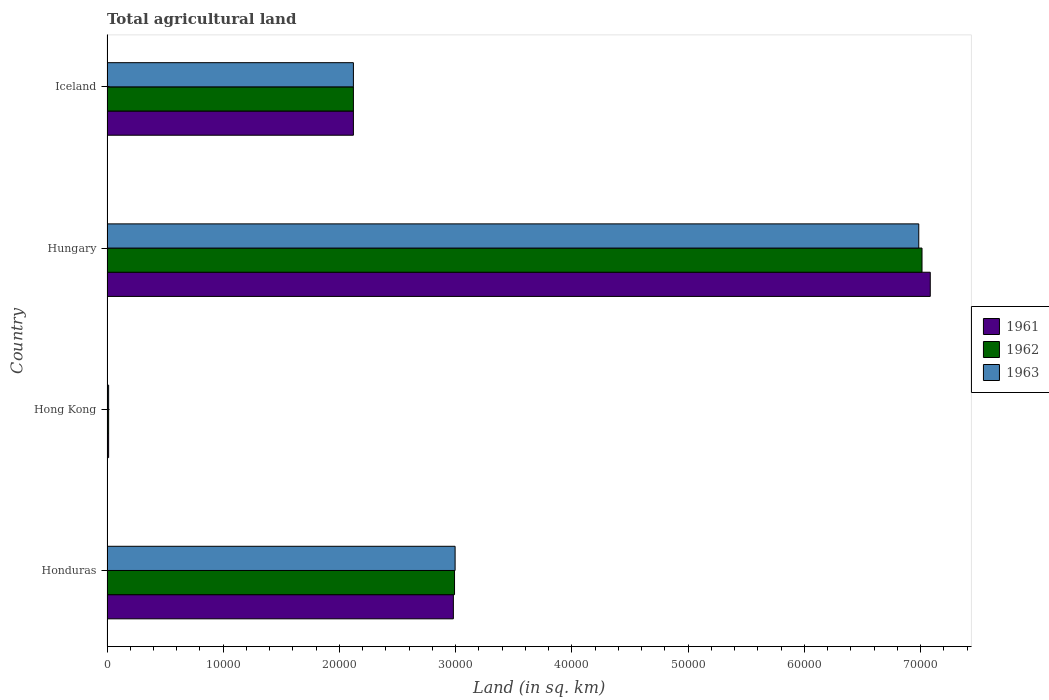How many groups of bars are there?
Keep it short and to the point. 4. Are the number of bars per tick equal to the number of legend labels?
Your answer should be very brief. Yes. How many bars are there on the 3rd tick from the bottom?
Your response must be concise. 3. What is the label of the 2nd group of bars from the top?
Your answer should be very brief. Hungary. In how many cases, is the number of bars for a given country not equal to the number of legend labels?
Give a very brief answer. 0. What is the total agricultural land in 1963 in Hungary?
Ensure brevity in your answer.  6.98e+04. Across all countries, what is the maximum total agricultural land in 1961?
Your answer should be compact. 7.08e+04. Across all countries, what is the minimum total agricultural land in 1962?
Offer a very short reply. 140. In which country was the total agricultural land in 1963 maximum?
Make the answer very short. Hungary. In which country was the total agricultural land in 1962 minimum?
Your answer should be very brief. Hong Kong. What is the total total agricultural land in 1961 in the graph?
Give a very brief answer. 1.22e+05. What is the difference between the total agricultural land in 1961 in Honduras and that in Iceland?
Provide a short and direct response. 8600. What is the difference between the total agricultural land in 1962 in Iceland and the total agricultural land in 1961 in Hungary?
Provide a succinct answer. -4.96e+04. What is the average total agricultural land in 1962 per country?
Give a very brief answer. 3.03e+04. What is the difference between the total agricultural land in 1961 and total agricultural land in 1963 in Honduras?
Offer a very short reply. -150. In how many countries, is the total agricultural land in 1963 greater than 72000 sq.km?
Ensure brevity in your answer.  0. What is the ratio of the total agricultural land in 1961 in Honduras to that in Hong Kong?
Make the answer very short. 212.86. Is the total agricultural land in 1963 in Hong Kong less than that in Iceland?
Offer a very short reply. Yes. What is the difference between the highest and the second highest total agricultural land in 1962?
Ensure brevity in your answer.  4.02e+04. What is the difference between the highest and the lowest total agricultural land in 1961?
Your answer should be compact. 7.07e+04. Is the sum of the total agricultural land in 1961 in Honduras and Hungary greater than the maximum total agricultural land in 1962 across all countries?
Make the answer very short. Yes. What does the 2nd bar from the bottom in Honduras represents?
Give a very brief answer. 1962. Is it the case that in every country, the sum of the total agricultural land in 1961 and total agricultural land in 1962 is greater than the total agricultural land in 1963?
Provide a succinct answer. Yes. Are all the bars in the graph horizontal?
Make the answer very short. Yes. What is the difference between two consecutive major ticks on the X-axis?
Your response must be concise. 10000. Are the values on the major ticks of X-axis written in scientific E-notation?
Ensure brevity in your answer.  No. Does the graph contain any zero values?
Provide a succinct answer. No. Where does the legend appear in the graph?
Give a very brief answer. Center right. What is the title of the graph?
Offer a very short reply. Total agricultural land. What is the label or title of the X-axis?
Provide a succinct answer. Land (in sq. km). What is the Land (in sq. km) in 1961 in Honduras?
Your response must be concise. 2.98e+04. What is the Land (in sq. km) of 1962 in Honduras?
Provide a succinct answer. 2.99e+04. What is the Land (in sq. km) of 1963 in Honduras?
Keep it short and to the point. 3.00e+04. What is the Land (in sq. km) in 1961 in Hong Kong?
Offer a terse response. 140. What is the Land (in sq. km) in 1962 in Hong Kong?
Your answer should be compact. 140. What is the Land (in sq. km) in 1963 in Hong Kong?
Provide a succinct answer. 140. What is the Land (in sq. km) in 1961 in Hungary?
Your answer should be very brief. 7.08e+04. What is the Land (in sq. km) of 1962 in Hungary?
Give a very brief answer. 7.01e+04. What is the Land (in sq. km) of 1963 in Hungary?
Offer a terse response. 6.98e+04. What is the Land (in sq. km) in 1961 in Iceland?
Your response must be concise. 2.12e+04. What is the Land (in sq. km) of 1962 in Iceland?
Your answer should be compact. 2.12e+04. What is the Land (in sq. km) of 1963 in Iceland?
Make the answer very short. 2.12e+04. Across all countries, what is the maximum Land (in sq. km) of 1961?
Your answer should be very brief. 7.08e+04. Across all countries, what is the maximum Land (in sq. km) in 1962?
Provide a short and direct response. 7.01e+04. Across all countries, what is the maximum Land (in sq. km) of 1963?
Make the answer very short. 6.98e+04. Across all countries, what is the minimum Land (in sq. km) of 1961?
Your answer should be very brief. 140. Across all countries, what is the minimum Land (in sq. km) of 1962?
Offer a very short reply. 140. Across all countries, what is the minimum Land (in sq. km) in 1963?
Offer a terse response. 140. What is the total Land (in sq. km) in 1961 in the graph?
Offer a very short reply. 1.22e+05. What is the total Land (in sq. km) of 1962 in the graph?
Your answer should be compact. 1.21e+05. What is the total Land (in sq. km) in 1963 in the graph?
Ensure brevity in your answer.  1.21e+05. What is the difference between the Land (in sq. km) in 1961 in Honduras and that in Hong Kong?
Make the answer very short. 2.97e+04. What is the difference between the Land (in sq. km) in 1962 in Honduras and that in Hong Kong?
Your response must be concise. 2.98e+04. What is the difference between the Land (in sq. km) in 1963 in Honduras and that in Hong Kong?
Provide a succinct answer. 2.98e+04. What is the difference between the Land (in sq. km) of 1961 in Honduras and that in Hungary?
Provide a succinct answer. -4.10e+04. What is the difference between the Land (in sq. km) in 1962 in Honduras and that in Hungary?
Keep it short and to the point. -4.02e+04. What is the difference between the Land (in sq. km) of 1963 in Honduras and that in Hungary?
Keep it short and to the point. -3.99e+04. What is the difference between the Land (in sq. km) in 1961 in Honduras and that in Iceland?
Your answer should be compact. 8600. What is the difference between the Land (in sq. km) of 1962 in Honduras and that in Iceland?
Your answer should be compact. 8700. What is the difference between the Land (in sq. km) of 1963 in Honduras and that in Iceland?
Provide a short and direct response. 8750. What is the difference between the Land (in sq. km) in 1961 in Hong Kong and that in Hungary?
Your answer should be compact. -7.07e+04. What is the difference between the Land (in sq. km) of 1962 in Hong Kong and that in Hungary?
Provide a short and direct response. -7.00e+04. What is the difference between the Land (in sq. km) of 1963 in Hong Kong and that in Hungary?
Provide a succinct answer. -6.97e+04. What is the difference between the Land (in sq. km) of 1961 in Hong Kong and that in Iceland?
Offer a terse response. -2.11e+04. What is the difference between the Land (in sq. km) of 1962 in Hong Kong and that in Iceland?
Make the answer very short. -2.11e+04. What is the difference between the Land (in sq. km) in 1963 in Hong Kong and that in Iceland?
Ensure brevity in your answer.  -2.11e+04. What is the difference between the Land (in sq. km) of 1961 in Hungary and that in Iceland?
Provide a short and direct response. 4.96e+04. What is the difference between the Land (in sq. km) of 1962 in Hungary and that in Iceland?
Keep it short and to the point. 4.89e+04. What is the difference between the Land (in sq. km) in 1963 in Hungary and that in Iceland?
Make the answer very short. 4.86e+04. What is the difference between the Land (in sq. km) of 1961 in Honduras and the Land (in sq. km) of 1962 in Hong Kong?
Give a very brief answer. 2.97e+04. What is the difference between the Land (in sq. km) in 1961 in Honduras and the Land (in sq. km) in 1963 in Hong Kong?
Your answer should be compact. 2.97e+04. What is the difference between the Land (in sq. km) in 1962 in Honduras and the Land (in sq. km) in 1963 in Hong Kong?
Keep it short and to the point. 2.98e+04. What is the difference between the Land (in sq. km) in 1961 in Honduras and the Land (in sq. km) in 1962 in Hungary?
Ensure brevity in your answer.  -4.03e+04. What is the difference between the Land (in sq. km) of 1961 in Honduras and the Land (in sq. km) of 1963 in Hungary?
Your response must be concise. -4.00e+04. What is the difference between the Land (in sq. km) in 1962 in Honduras and the Land (in sq. km) in 1963 in Hungary?
Make the answer very short. -3.99e+04. What is the difference between the Land (in sq. km) of 1961 in Honduras and the Land (in sq. km) of 1962 in Iceland?
Offer a terse response. 8600. What is the difference between the Land (in sq. km) in 1961 in Honduras and the Land (in sq. km) in 1963 in Iceland?
Your response must be concise. 8600. What is the difference between the Land (in sq. km) of 1962 in Honduras and the Land (in sq. km) of 1963 in Iceland?
Ensure brevity in your answer.  8700. What is the difference between the Land (in sq. km) in 1961 in Hong Kong and the Land (in sq. km) in 1962 in Hungary?
Your answer should be compact. -7.00e+04. What is the difference between the Land (in sq. km) of 1961 in Hong Kong and the Land (in sq. km) of 1963 in Hungary?
Your answer should be very brief. -6.97e+04. What is the difference between the Land (in sq. km) of 1962 in Hong Kong and the Land (in sq. km) of 1963 in Hungary?
Provide a short and direct response. -6.97e+04. What is the difference between the Land (in sq. km) in 1961 in Hong Kong and the Land (in sq. km) in 1962 in Iceland?
Ensure brevity in your answer.  -2.11e+04. What is the difference between the Land (in sq. km) in 1961 in Hong Kong and the Land (in sq. km) in 1963 in Iceland?
Your answer should be compact. -2.11e+04. What is the difference between the Land (in sq. km) in 1962 in Hong Kong and the Land (in sq. km) in 1963 in Iceland?
Offer a very short reply. -2.11e+04. What is the difference between the Land (in sq. km) in 1961 in Hungary and the Land (in sq. km) in 1962 in Iceland?
Make the answer very short. 4.96e+04. What is the difference between the Land (in sq. km) in 1961 in Hungary and the Land (in sq. km) in 1963 in Iceland?
Keep it short and to the point. 4.96e+04. What is the difference between the Land (in sq. km) of 1962 in Hungary and the Land (in sq. km) of 1963 in Iceland?
Your answer should be compact. 4.89e+04. What is the average Land (in sq. km) in 1961 per country?
Your response must be concise. 3.05e+04. What is the average Land (in sq. km) of 1962 per country?
Keep it short and to the point. 3.03e+04. What is the average Land (in sq. km) of 1963 per country?
Your answer should be very brief. 3.03e+04. What is the difference between the Land (in sq. km) in 1961 and Land (in sq. km) in 1962 in Honduras?
Offer a very short reply. -100. What is the difference between the Land (in sq. km) of 1961 and Land (in sq. km) of 1963 in Honduras?
Your answer should be very brief. -150. What is the difference between the Land (in sq. km) of 1962 and Land (in sq. km) of 1963 in Honduras?
Your answer should be compact. -50. What is the difference between the Land (in sq. km) of 1961 and Land (in sq. km) of 1962 in Hong Kong?
Provide a short and direct response. 0. What is the difference between the Land (in sq. km) in 1961 and Land (in sq. km) in 1963 in Hong Kong?
Provide a short and direct response. 0. What is the difference between the Land (in sq. km) in 1962 and Land (in sq. km) in 1963 in Hong Kong?
Give a very brief answer. 0. What is the difference between the Land (in sq. km) of 1961 and Land (in sq. km) of 1962 in Hungary?
Provide a succinct answer. 710. What is the difference between the Land (in sq. km) in 1961 and Land (in sq. km) in 1963 in Hungary?
Ensure brevity in your answer.  990. What is the difference between the Land (in sq. km) in 1962 and Land (in sq. km) in 1963 in Hungary?
Make the answer very short. 280. What is the difference between the Land (in sq. km) in 1961 and Land (in sq. km) in 1963 in Iceland?
Your answer should be compact. 0. What is the difference between the Land (in sq. km) in 1962 and Land (in sq. km) in 1963 in Iceland?
Provide a succinct answer. 0. What is the ratio of the Land (in sq. km) in 1961 in Honduras to that in Hong Kong?
Your answer should be very brief. 212.86. What is the ratio of the Land (in sq. km) in 1962 in Honduras to that in Hong Kong?
Offer a very short reply. 213.57. What is the ratio of the Land (in sq. km) of 1963 in Honduras to that in Hong Kong?
Offer a terse response. 213.93. What is the ratio of the Land (in sq. km) in 1961 in Honduras to that in Hungary?
Your answer should be compact. 0.42. What is the ratio of the Land (in sq. km) of 1962 in Honduras to that in Hungary?
Provide a succinct answer. 0.43. What is the ratio of the Land (in sq. km) of 1963 in Honduras to that in Hungary?
Your answer should be compact. 0.43. What is the ratio of the Land (in sq. km) of 1961 in Honduras to that in Iceland?
Your answer should be compact. 1.41. What is the ratio of the Land (in sq. km) of 1962 in Honduras to that in Iceland?
Keep it short and to the point. 1.41. What is the ratio of the Land (in sq. km) in 1963 in Honduras to that in Iceland?
Give a very brief answer. 1.41. What is the ratio of the Land (in sq. km) in 1961 in Hong Kong to that in Hungary?
Give a very brief answer. 0. What is the ratio of the Land (in sq. km) of 1962 in Hong Kong to that in Hungary?
Make the answer very short. 0. What is the ratio of the Land (in sq. km) in 1963 in Hong Kong to that in Hungary?
Provide a short and direct response. 0. What is the ratio of the Land (in sq. km) in 1961 in Hong Kong to that in Iceland?
Provide a short and direct response. 0.01. What is the ratio of the Land (in sq. km) of 1962 in Hong Kong to that in Iceland?
Keep it short and to the point. 0.01. What is the ratio of the Land (in sq. km) in 1963 in Hong Kong to that in Iceland?
Provide a short and direct response. 0.01. What is the ratio of the Land (in sq. km) in 1961 in Hungary to that in Iceland?
Ensure brevity in your answer.  3.34. What is the ratio of the Land (in sq. km) in 1962 in Hungary to that in Iceland?
Your answer should be compact. 3.31. What is the ratio of the Land (in sq. km) of 1963 in Hungary to that in Iceland?
Make the answer very short. 3.29. What is the difference between the highest and the second highest Land (in sq. km) of 1961?
Your answer should be compact. 4.10e+04. What is the difference between the highest and the second highest Land (in sq. km) in 1962?
Provide a succinct answer. 4.02e+04. What is the difference between the highest and the second highest Land (in sq. km) in 1963?
Provide a short and direct response. 3.99e+04. What is the difference between the highest and the lowest Land (in sq. km) of 1961?
Provide a short and direct response. 7.07e+04. What is the difference between the highest and the lowest Land (in sq. km) in 1962?
Keep it short and to the point. 7.00e+04. What is the difference between the highest and the lowest Land (in sq. km) in 1963?
Keep it short and to the point. 6.97e+04. 